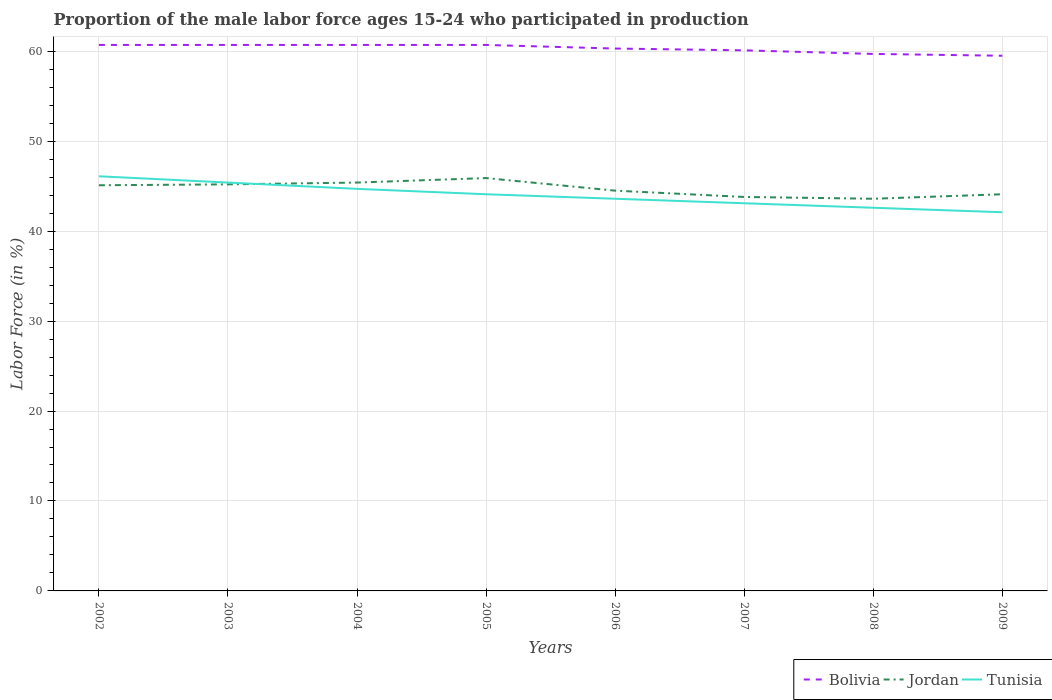Is the number of lines equal to the number of legend labels?
Offer a very short reply. Yes. Across all years, what is the maximum proportion of the male labor force who participated in production in Tunisia?
Provide a short and direct response. 42.1. In which year was the proportion of the male labor force who participated in production in Bolivia maximum?
Provide a short and direct response. 2009. What is the total proportion of the male labor force who participated in production in Bolivia in the graph?
Your response must be concise. 0.6. What is the difference between the highest and the lowest proportion of the male labor force who participated in production in Tunisia?
Make the answer very short. 4. Does the graph contain grids?
Provide a succinct answer. Yes. How many legend labels are there?
Keep it short and to the point. 3. What is the title of the graph?
Your answer should be compact. Proportion of the male labor force ages 15-24 who participated in production. What is the label or title of the X-axis?
Provide a succinct answer. Years. What is the Labor Force (in %) in Bolivia in 2002?
Offer a very short reply. 60.7. What is the Labor Force (in %) in Jordan in 2002?
Provide a short and direct response. 45.1. What is the Labor Force (in %) in Tunisia in 2002?
Ensure brevity in your answer.  46.1. What is the Labor Force (in %) in Bolivia in 2003?
Provide a short and direct response. 60.7. What is the Labor Force (in %) of Jordan in 2003?
Offer a terse response. 45.2. What is the Labor Force (in %) of Tunisia in 2003?
Your response must be concise. 45.4. What is the Labor Force (in %) in Bolivia in 2004?
Ensure brevity in your answer.  60.7. What is the Labor Force (in %) in Jordan in 2004?
Your answer should be compact. 45.4. What is the Labor Force (in %) in Tunisia in 2004?
Offer a very short reply. 44.7. What is the Labor Force (in %) of Bolivia in 2005?
Your response must be concise. 60.7. What is the Labor Force (in %) in Jordan in 2005?
Your response must be concise. 45.9. What is the Labor Force (in %) in Tunisia in 2005?
Provide a short and direct response. 44.1. What is the Labor Force (in %) of Bolivia in 2006?
Provide a succinct answer. 60.3. What is the Labor Force (in %) of Jordan in 2006?
Give a very brief answer. 44.5. What is the Labor Force (in %) of Tunisia in 2006?
Ensure brevity in your answer.  43.6. What is the Labor Force (in %) in Bolivia in 2007?
Your answer should be compact. 60.1. What is the Labor Force (in %) in Jordan in 2007?
Make the answer very short. 43.8. What is the Labor Force (in %) of Tunisia in 2007?
Ensure brevity in your answer.  43.1. What is the Labor Force (in %) in Bolivia in 2008?
Offer a terse response. 59.7. What is the Labor Force (in %) in Jordan in 2008?
Your response must be concise. 43.6. What is the Labor Force (in %) of Tunisia in 2008?
Ensure brevity in your answer.  42.6. What is the Labor Force (in %) in Bolivia in 2009?
Make the answer very short. 59.5. What is the Labor Force (in %) of Jordan in 2009?
Provide a succinct answer. 44.1. What is the Labor Force (in %) of Tunisia in 2009?
Provide a short and direct response. 42.1. Across all years, what is the maximum Labor Force (in %) of Bolivia?
Your response must be concise. 60.7. Across all years, what is the maximum Labor Force (in %) of Jordan?
Give a very brief answer. 45.9. Across all years, what is the maximum Labor Force (in %) of Tunisia?
Your answer should be compact. 46.1. Across all years, what is the minimum Labor Force (in %) in Bolivia?
Ensure brevity in your answer.  59.5. Across all years, what is the minimum Labor Force (in %) in Jordan?
Offer a terse response. 43.6. Across all years, what is the minimum Labor Force (in %) in Tunisia?
Make the answer very short. 42.1. What is the total Labor Force (in %) in Bolivia in the graph?
Keep it short and to the point. 482.4. What is the total Labor Force (in %) in Jordan in the graph?
Offer a terse response. 357.6. What is the total Labor Force (in %) of Tunisia in the graph?
Ensure brevity in your answer.  351.7. What is the difference between the Labor Force (in %) of Bolivia in 2002 and that in 2003?
Offer a terse response. 0. What is the difference between the Labor Force (in %) of Tunisia in 2002 and that in 2003?
Offer a very short reply. 0.7. What is the difference between the Labor Force (in %) of Tunisia in 2002 and that in 2004?
Your answer should be very brief. 1.4. What is the difference between the Labor Force (in %) of Jordan in 2002 and that in 2005?
Give a very brief answer. -0.8. What is the difference between the Labor Force (in %) in Bolivia in 2002 and that in 2006?
Provide a short and direct response. 0.4. What is the difference between the Labor Force (in %) in Jordan in 2002 and that in 2006?
Provide a succinct answer. 0.6. What is the difference between the Labor Force (in %) in Tunisia in 2002 and that in 2006?
Your answer should be very brief. 2.5. What is the difference between the Labor Force (in %) in Bolivia in 2002 and that in 2008?
Offer a very short reply. 1. What is the difference between the Labor Force (in %) of Jordan in 2002 and that in 2008?
Make the answer very short. 1.5. What is the difference between the Labor Force (in %) in Tunisia in 2002 and that in 2008?
Give a very brief answer. 3.5. What is the difference between the Labor Force (in %) in Jordan in 2002 and that in 2009?
Ensure brevity in your answer.  1. What is the difference between the Labor Force (in %) in Bolivia in 2003 and that in 2004?
Your answer should be very brief. 0. What is the difference between the Labor Force (in %) of Bolivia in 2003 and that in 2005?
Your answer should be very brief. 0. What is the difference between the Labor Force (in %) in Jordan in 2003 and that in 2006?
Provide a succinct answer. 0.7. What is the difference between the Labor Force (in %) in Tunisia in 2003 and that in 2006?
Your response must be concise. 1.8. What is the difference between the Labor Force (in %) in Jordan in 2003 and that in 2007?
Your response must be concise. 1.4. What is the difference between the Labor Force (in %) in Jordan in 2003 and that in 2008?
Offer a terse response. 1.6. What is the difference between the Labor Force (in %) in Tunisia in 2003 and that in 2008?
Offer a terse response. 2.8. What is the difference between the Labor Force (in %) in Bolivia in 2003 and that in 2009?
Give a very brief answer. 1.2. What is the difference between the Labor Force (in %) in Jordan in 2003 and that in 2009?
Ensure brevity in your answer.  1.1. What is the difference between the Labor Force (in %) in Tunisia in 2003 and that in 2009?
Make the answer very short. 3.3. What is the difference between the Labor Force (in %) of Bolivia in 2004 and that in 2005?
Provide a succinct answer. 0. What is the difference between the Labor Force (in %) in Jordan in 2004 and that in 2006?
Your answer should be compact. 0.9. What is the difference between the Labor Force (in %) of Tunisia in 2004 and that in 2006?
Offer a very short reply. 1.1. What is the difference between the Labor Force (in %) of Jordan in 2004 and that in 2007?
Give a very brief answer. 1.6. What is the difference between the Labor Force (in %) of Tunisia in 2004 and that in 2007?
Provide a succinct answer. 1.6. What is the difference between the Labor Force (in %) in Bolivia in 2004 and that in 2008?
Offer a terse response. 1. What is the difference between the Labor Force (in %) in Jordan in 2004 and that in 2008?
Make the answer very short. 1.8. What is the difference between the Labor Force (in %) of Tunisia in 2004 and that in 2009?
Your response must be concise. 2.6. What is the difference between the Labor Force (in %) of Jordan in 2005 and that in 2006?
Your response must be concise. 1.4. What is the difference between the Labor Force (in %) in Jordan in 2005 and that in 2007?
Make the answer very short. 2.1. What is the difference between the Labor Force (in %) in Bolivia in 2005 and that in 2008?
Ensure brevity in your answer.  1. What is the difference between the Labor Force (in %) of Jordan in 2005 and that in 2008?
Provide a short and direct response. 2.3. What is the difference between the Labor Force (in %) in Bolivia in 2005 and that in 2009?
Provide a succinct answer. 1.2. What is the difference between the Labor Force (in %) in Jordan in 2005 and that in 2009?
Ensure brevity in your answer.  1.8. What is the difference between the Labor Force (in %) in Bolivia in 2006 and that in 2007?
Offer a terse response. 0.2. What is the difference between the Labor Force (in %) in Bolivia in 2006 and that in 2008?
Ensure brevity in your answer.  0.6. What is the difference between the Labor Force (in %) in Bolivia in 2006 and that in 2009?
Give a very brief answer. 0.8. What is the difference between the Labor Force (in %) in Jordan in 2006 and that in 2009?
Offer a very short reply. 0.4. What is the difference between the Labor Force (in %) of Tunisia in 2006 and that in 2009?
Provide a short and direct response. 1.5. What is the difference between the Labor Force (in %) in Jordan in 2007 and that in 2008?
Ensure brevity in your answer.  0.2. What is the difference between the Labor Force (in %) in Tunisia in 2007 and that in 2008?
Provide a short and direct response. 0.5. What is the difference between the Labor Force (in %) of Bolivia in 2007 and that in 2009?
Provide a short and direct response. 0.6. What is the difference between the Labor Force (in %) of Jordan in 2007 and that in 2009?
Make the answer very short. -0.3. What is the difference between the Labor Force (in %) of Bolivia in 2002 and the Labor Force (in %) of Jordan in 2005?
Make the answer very short. 14.8. What is the difference between the Labor Force (in %) in Jordan in 2002 and the Labor Force (in %) in Tunisia in 2005?
Your response must be concise. 1. What is the difference between the Labor Force (in %) of Bolivia in 2002 and the Labor Force (in %) of Jordan in 2008?
Ensure brevity in your answer.  17.1. What is the difference between the Labor Force (in %) in Bolivia in 2002 and the Labor Force (in %) in Tunisia in 2008?
Offer a terse response. 18.1. What is the difference between the Labor Force (in %) in Jordan in 2002 and the Labor Force (in %) in Tunisia in 2008?
Keep it short and to the point. 2.5. What is the difference between the Labor Force (in %) of Bolivia in 2002 and the Labor Force (in %) of Jordan in 2009?
Provide a succinct answer. 16.6. What is the difference between the Labor Force (in %) in Bolivia in 2002 and the Labor Force (in %) in Tunisia in 2009?
Ensure brevity in your answer.  18.6. What is the difference between the Labor Force (in %) in Bolivia in 2003 and the Labor Force (in %) in Jordan in 2004?
Offer a terse response. 15.3. What is the difference between the Labor Force (in %) of Bolivia in 2003 and the Labor Force (in %) of Tunisia in 2004?
Keep it short and to the point. 16. What is the difference between the Labor Force (in %) of Jordan in 2003 and the Labor Force (in %) of Tunisia in 2004?
Keep it short and to the point. 0.5. What is the difference between the Labor Force (in %) of Bolivia in 2003 and the Labor Force (in %) of Tunisia in 2005?
Keep it short and to the point. 16.6. What is the difference between the Labor Force (in %) in Jordan in 2003 and the Labor Force (in %) in Tunisia in 2005?
Offer a terse response. 1.1. What is the difference between the Labor Force (in %) in Bolivia in 2003 and the Labor Force (in %) in Jordan in 2006?
Provide a succinct answer. 16.2. What is the difference between the Labor Force (in %) in Bolivia in 2003 and the Labor Force (in %) in Jordan in 2007?
Provide a short and direct response. 16.9. What is the difference between the Labor Force (in %) in Bolivia in 2004 and the Labor Force (in %) in Tunisia in 2006?
Provide a short and direct response. 17.1. What is the difference between the Labor Force (in %) of Jordan in 2004 and the Labor Force (in %) of Tunisia in 2006?
Make the answer very short. 1.8. What is the difference between the Labor Force (in %) in Jordan in 2004 and the Labor Force (in %) in Tunisia in 2008?
Your answer should be compact. 2.8. What is the difference between the Labor Force (in %) of Bolivia in 2004 and the Labor Force (in %) of Jordan in 2009?
Offer a very short reply. 16.6. What is the difference between the Labor Force (in %) in Bolivia in 2004 and the Labor Force (in %) in Tunisia in 2009?
Your answer should be very brief. 18.6. What is the difference between the Labor Force (in %) in Jordan in 2005 and the Labor Force (in %) in Tunisia in 2006?
Offer a very short reply. 2.3. What is the difference between the Labor Force (in %) of Bolivia in 2005 and the Labor Force (in %) of Jordan in 2007?
Make the answer very short. 16.9. What is the difference between the Labor Force (in %) in Jordan in 2005 and the Labor Force (in %) in Tunisia in 2008?
Make the answer very short. 3.3. What is the difference between the Labor Force (in %) of Bolivia in 2006 and the Labor Force (in %) of Tunisia in 2007?
Make the answer very short. 17.2. What is the difference between the Labor Force (in %) in Jordan in 2006 and the Labor Force (in %) in Tunisia in 2007?
Your answer should be compact. 1.4. What is the difference between the Labor Force (in %) of Bolivia in 2006 and the Labor Force (in %) of Jordan in 2008?
Your answer should be very brief. 16.7. What is the difference between the Labor Force (in %) in Bolivia in 2006 and the Labor Force (in %) in Tunisia in 2008?
Ensure brevity in your answer.  17.7. What is the difference between the Labor Force (in %) of Jordan in 2006 and the Labor Force (in %) of Tunisia in 2008?
Keep it short and to the point. 1.9. What is the difference between the Labor Force (in %) in Bolivia in 2006 and the Labor Force (in %) in Tunisia in 2009?
Give a very brief answer. 18.2. What is the difference between the Labor Force (in %) in Jordan in 2006 and the Labor Force (in %) in Tunisia in 2009?
Ensure brevity in your answer.  2.4. What is the difference between the Labor Force (in %) in Bolivia in 2007 and the Labor Force (in %) in Jordan in 2008?
Offer a very short reply. 16.5. What is the difference between the Labor Force (in %) of Jordan in 2007 and the Labor Force (in %) of Tunisia in 2008?
Keep it short and to the point. 1.2. What is the difference between the Labor Force (in %) in Bolivia in 2007 and the Labor Force (in %) in Jordan in 2009?
Give a very brief answer. 16. What is the difference between the Labor Force (in %) in Jordan in 2007 and the Labor Force (in %) in Tunisia in 2009?
Your answer should be very brief. 1.7. What is the difference between the Labor Force (in %) in Bolivia in 2008 and the Labor Force (in %) in Jordan in 2009?
Make the answer very short. 15.6. What is the difference between the Labor Force (in %) in Bolivia in 2008 and the Labor Force (in %) in Tunisia in 2009?
Your answer should be compact. 17.6. What is the average Labor Force (in %) in Bolivia per year?
Your response must be concise. 60.3. What is the average Labor Force (in %) of Jordan per year?
Your response must be concise. 44.7. What is the average Labor Force (in %) of Tunisia per year?
Give a very brief answer. 43.96. In the year 2002, what is the difference between the Labor Force (in %) in Bolivia and Labor Force (in %) in Tunisia?
Keep it short and to the point. 14.6. In the year 2002, what is the difference between the Labor Force (in %) of Jordan and Labor Force (in %) of Tunisia?
Your answer should be very brief. -1. In the year 2003, what is the difference between the Labor Force (in %) in Jordan and Labor Force (in %) in Tunisia?
Provide a short and direct response. -0.2. In the year 2004, what is the difference between the Labor Force (in %) in Jordan and Labor Force (in %) in Tunisia?
Provide a short and direct response. 0.7. In the year 2005, what is the difference between the Labor Force (in %) of Bolivia and Labor Force (in %) of Jordan?
Give a very brief answer. 14.8. In the year 2005, what is the difference between the Labor Force (in %) in Bolivia and Labor Force (in %) in Tunisia?
Provide a succinct answer. 16.6. In the year 2005, what is the difference between the Labor Force (in %) of Jordan and Labor Force (in %) of Tunisia?
Your answer should be very brief. 1.8. In the year 2006, what is the difference between the Labor Force (in %) in Bolivia and Labor Force (in %) in Jordan?
Give a very brief answer. 15.8. In the year 2007, what is the difference between the Labor Force (in %) of Bolivia and Labor Force (in %) of Tunisia?
Ensure brevity in your answer.  17. In the year 2007, what is the difference between the Labor Force (in %) of Jordan and Labor Force (in %) of Tunisia?
Offer a terse response. 0.7. In the year 2008, what is the difference between the Labor Force (in %) in Bolivia and Labor Force (in %) in Tunisia?
Keep it short and to the point. 17.1. In the year 2008, what is the difference between the Labor Force (in %) of Jordan and Labor Force (in %) of Tunisia?
Your answer should be compact. 1. In the year 2009, what is the difference between the Labor Force (in %) in Bolivia and Labor Force (in %) in Jordan?
Give a very brief answer. 15.4. In the year 2009, what is the difference between the Labor Force (in %) in Bolivia and Labor Force (in %) in Tunisia?
Ensure brevity in your answer.  17.4. What is the ratio of the Labor Force (in %) of Tunisia in 2002 to that in 2003?
Your answer should be very brief. 1.02. What is the ratio of the Labor Force (in %) of Jordan in 2002 to that in 2004?
Provide a short and direct response. 0.99. What is the ratio of the Labor Force (in %) in Tunisia in 2002 to that in 2004?
Your answer should be compact. 1.03. What is the ratio of the Labor Force (in %) of Bolivia in 2002 to that in 2005?
Ensure brevity in your answer.  1. What is the ratio of the Labor Force (in %) in Jordan in 2002 to that in 2005?
Provide a succinct answer. 0.98. What is the ratio of the Labor Force (in %) in Tunisia in 2002 to that in 2005?
Keep it short and to the point. 1.05. What is the ratio of the Labor Force (in %) in Bolivia in 2002 to that in 2006?
Provide a short and direct response. 1.01. What is the ratio of the Labor Force (in %) in Jordan in 2002 to that in 2006?
Give a very brief answer. 1.01. What is the ratio of the Labor Force (in %) of Tunisia in 2002 to that in 2006?
Offer a very short reply. 1.06. What is the ratio of the Labor Force (in %) in Jordan in 2002 to that in 2007?
Keep it short and to the point. 1.03. What is the ratio of the Labor Force (in %) in Tunisia in 2002 to that in 2007?
Offer a terse response. 1.07. What is the ratio of the Labor Force (in %) in Bolivia in 2002 to that in 2008?
Provide a short and direct response. 1.02. What is the ratio of the Labor Force (in %) of Jordan in 2002 to that in 2008?
Make the answer very short. 1.03. What is the ratio of the Labor Force (in %) of Tunisia in 2002 to that in 2008?
Make the answer very short. 1.08. What is the ratio of the Labor Force (in %) in Bolivia in 2002 to that in 2009?
Keep it short and to the point. 1.02. What is the ratio of the Labor Force (in %) in Jordan in 2002 to that in 2009?
Your answer should be very brief. 1.02. What is the ratio of the Labor Force (in %) of Tunisia in 2002 to that in 2009?
Your answer should be compact. 1.09. What is the ratio of the Labor Force (in %) in Bolivia in 2003 to that in 2004?
Make the answer very short. 1. What is the ratio of the Labor Force (in %) in Tunisia in 2003 to that in 2004?
Offer a very short reply. 1.02. What is the ratio of the Labor Force (in %) of Bolivia in 2003 to that in 2005?
Ensure brevity in your answer.  1. What is the ratio of the Labor Force (in %) in Jordan in 2003 to that in 2005?
Offer a terse response. 0.98. What is the ratio of the Labor Force (in %) in Tunisia in 2003 to that in 2005?
Offer a very short reply. 1.03. What is the ratio of the Labor Force (in %) in Bolivia in 2003 to that in 2006?
Ensure brevity in your answer.  1.01. What is the ratio of the Labor Force (in %) in Jordan in 2003 to that in 2006?
Offer a very short reply. 1.02. What is the ratio of the Labor Force (in %) of Tunisia in 2003 to that in 2006?
Make the answer very short. 1.04. What is the ratio of the Labor Force (in %) in Jordan in 2003 to that in 2007?
Provide a short and direct response. 1.03. What is the ratio of the Labor Force (in %) of Tunisia in 2003 to that in 2007?
Provide a succinct answer. 1.05. What is the ratio of the Labor Force (in %) of Bolivia in 2003 to that in 2008?
Provide a succinct answer. 1.02. What is the ratio of the Labor Force (in %) in Jordan in 2003 to that in 2008?
Keep it short and to the point. 1.04. What is the ratio of the Labor Force (in %) of Tunisia in 2003 to that in 2008?
Offer a very short reply. 1.07. What is the ratio of the Labor Force (in %) in Bolivia in 2003 to that in 2009?
Make the answer very short. 1.02. What is the ratio of the Labor Force (in %) in Jordan in 2003 to that in 2009?
Provide a succinct answer. 1.02. What is the ratio of the Labor Force (in %) in Tunisia in 2003 to that in 2009?
Make the answer very short. 1.08. What is the ratio of the Labor Force (in %) in Bolivia in 2004 to that in 2005?
Ensure brevity in your answer.  1. What is the ratio of the Labor Force (in %) of Jordan in 2004 to that in 2005?
Make the answer very short. 0.99. What is the ratio of the Labor Force (in %) in Tunisia in 2004 to that in 2005?
Provide a short and direct response. 1.01. What is the ratio of the Labor Force (in %) in Bolivia in 2004 to that in 2006?
Your answer should be very brief. 1.01. What is the ratio of the Labor Force (in %) of Jordan in 2004 to that in 2006?
Your answer should be compact. 1.02. What is the ratio of the Labor Force (in %) in Tunisia in 2004 to that in 2006?
Your answer should be very brief. 1.03. What is the ratio of the Labor Force (in %) in Bolivia in 2004 to that in 2007?
Ensure brevity in your answer.  1.01. What is the ratio of the Labor Force (in %) of Jordan in 2004 to that in 2007?
Offer a terse response. 1.04. What is the ratio of the Labor Force (in %) of Tunisia in 2004 to that in 2007?
Your response must be concise. 1.04. What is the ratio of the Labor Force (in %) in Bolivia in 2004 to that in 2008?
Offer a terse response. 1.02. What is the ratio of the Labor Force (in %) in Jordan in 2004 to that in 2008?
Keep it short and to the point. 1.04. What is the ratio of the Labor Force (in %) of Tunisia in 2004 to that in 2008?
Your answer should be compact. 1.05. What is the ratio of the Labor Force (in %) in Bolivia in 2004 to that in 2009?
Offer a terse response. 1.02. What is the ratio of the Labor Force (in %) in Jordan in 2004 to that in 2009?
Ensure brevity in your answer.  1.03. What is the ratio of the Labor Force (in %) of Tunisia in 2004 to that in 2009?
Provide a succinct answer. 1.06. What is the ratio of the Labor Force (in %) of Bolivia in 2005 to that in 2006?
Your answer should be very brief. 1.01. What is the ratio of the Labor Force (in %) in Jordan in 2005 to that in 2006?
Provide a short and direct response. 1.03. What is the ratio of the Labor Force (in %) of Tunisia in 2005 to that in 2006?
Offer a very short reply. 1.01. What is the ratio of the Labor Force (in %) in Bolivia in 2005 to that in 2007?
Offer a terse response. 1.01. What is the ratio of the Labor Force (in %) of Jordan in 2005 to that in 2007?
Ensure brevity in your answer.  1.05. What is the ratio of the Labor Force (in %) in Tunisia in 2005 to that in 2007?
Make the answer very short. 1.02. What is the ratio of the Labor Force (in %) of Bolivia in 2005 to that in 2008?
Offer a very short reply. 1.02. What is the ratio of the Labor Force (in %) in Jordan in 2005 to that in 2008?
Provide a short and direct response. 1.05. What is the ratio of the Labor Force (in %) in Tunisia in 2005 to that in 2008?
Your answer should be compact. 1.04. What is the ratio of the Labor Force (in %) in Bolivia in 2005 to that in 2009?
Your response must be concise. 1.02. What is the ratio of the Labor Force (in %) in Jordan in 2005 to that in 2009?
Ensure brevity in your answer.  1.04. What is the ratio of the Labor Force (in %) of Tunisia in 2005 to that in 2009?
Give a very brief answer. 1.05. What is the ratio of the Labor Force (in %) of Tunisia in 2006 to that in 2007?
Offer a terse response. 1.01. What is the ratio of the Labor Force (in %) of Bolivia in 2006 to that in 2008?
Give a very brief answer. 1.01. What is the ratio of the Labor Force (in %) in Jordan in 2006 to that in 2008?
Offer a terse response. 1.02. What is the ratio of the Labor Force (in %) of Tunisia in 2006 to that in 2008?
Your answer should be compact. 1.02. What is the ratio of the Labor Force (in %) in Bolivia in 2006 to that in 2009?
Keep it short and to the point. 1.01. What is the ratio of the Labor Force (in %) in Jordan in 2006 to that in 2009?
Provide a succinct answer. 1.01. What is the ratio of the Labor Force (in %) in Tunisia in 2006 to that in 2009?
Your response must be concise. 1.04. What is the ratio of the Labor Force (in %) in Bolivia in 2007 to that in 2008?
Your answer should be very brief. 1.01. What is the ratio of the Labor Force (in %) in Tunisia in 2007 to that in 2008?
Give a very brief answer. 1.01. What is the ratio of the Labor Force (in %) in Bolivia in 2007 to that in 2009?
Provide a short and direct response. 1.01. What is the ratio of the Labor Force (in %) of Tunisia in 2007 to that in 2009?
Offer a very short reply. 1.02. What is the ratio of the Labor Force (in %) in Bolivia in 2008 to that in 2009?
Make the answer very short. 1. What is the ratio of the Labor Force (in %) in Jordan in 2008 to that in 2009?
Your answer should be very brief. 0.99. What is the ratio of the Labor Force (in %) in Tunisia in 2008 to that in 2009?
Your response must be concise. 1.01. What is the difference between the highest and the second highest Labor Force (in %) in Bolivia?
Offer a terse response. 0. What is the difference between the highest and the second highest Labor Force (in %) of Jordan?
Keep it short and to the point. 0.5. What is the difference between the highest and the second highest Labor Force (in %) of Tunisia?
Offer a terse response. 0.7. What is the difference between the highest and the lowest Labor Force (in %) of Bolivia?
Offer a terse response. 1.2. What is the difference between the highest and the lowest Labor Force (in %) of Jordan?
Offer a very short reply. 2.3. What is the difference between the highest and the lowest Labor Force (in %) in Tunisia?
Give a very brief answer. 4. 